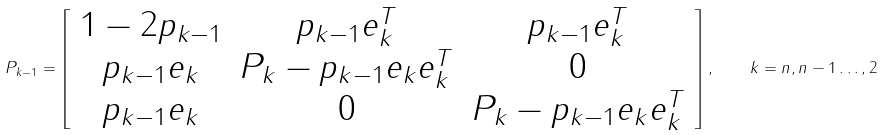Convert formula to latex. <formula><loc_0><loc_0><loc_500><loc_500>P _ { k - 1 } = \left [ \begin{array} { c c c } 1 - 2 p _ { k - 1 } & p _ { k - 1 } e _ { k } ^ { T } & p _ { k - 1 } e _ { k } ^ { T } \\ p _ { k - 1 } e _ { k } & P _ { k } - p _ { k - 1 } e _ { k } e _ { k } ^ { T } & 0 \\ p _ { k - 1 } e _ { k } & 0 & P _ { k } - p _ { k - 1 } e _ { k } e _ { k } ^ { T } \end{array} \right ] , \quad k = n , n - 1 \dots , 2</formula> 